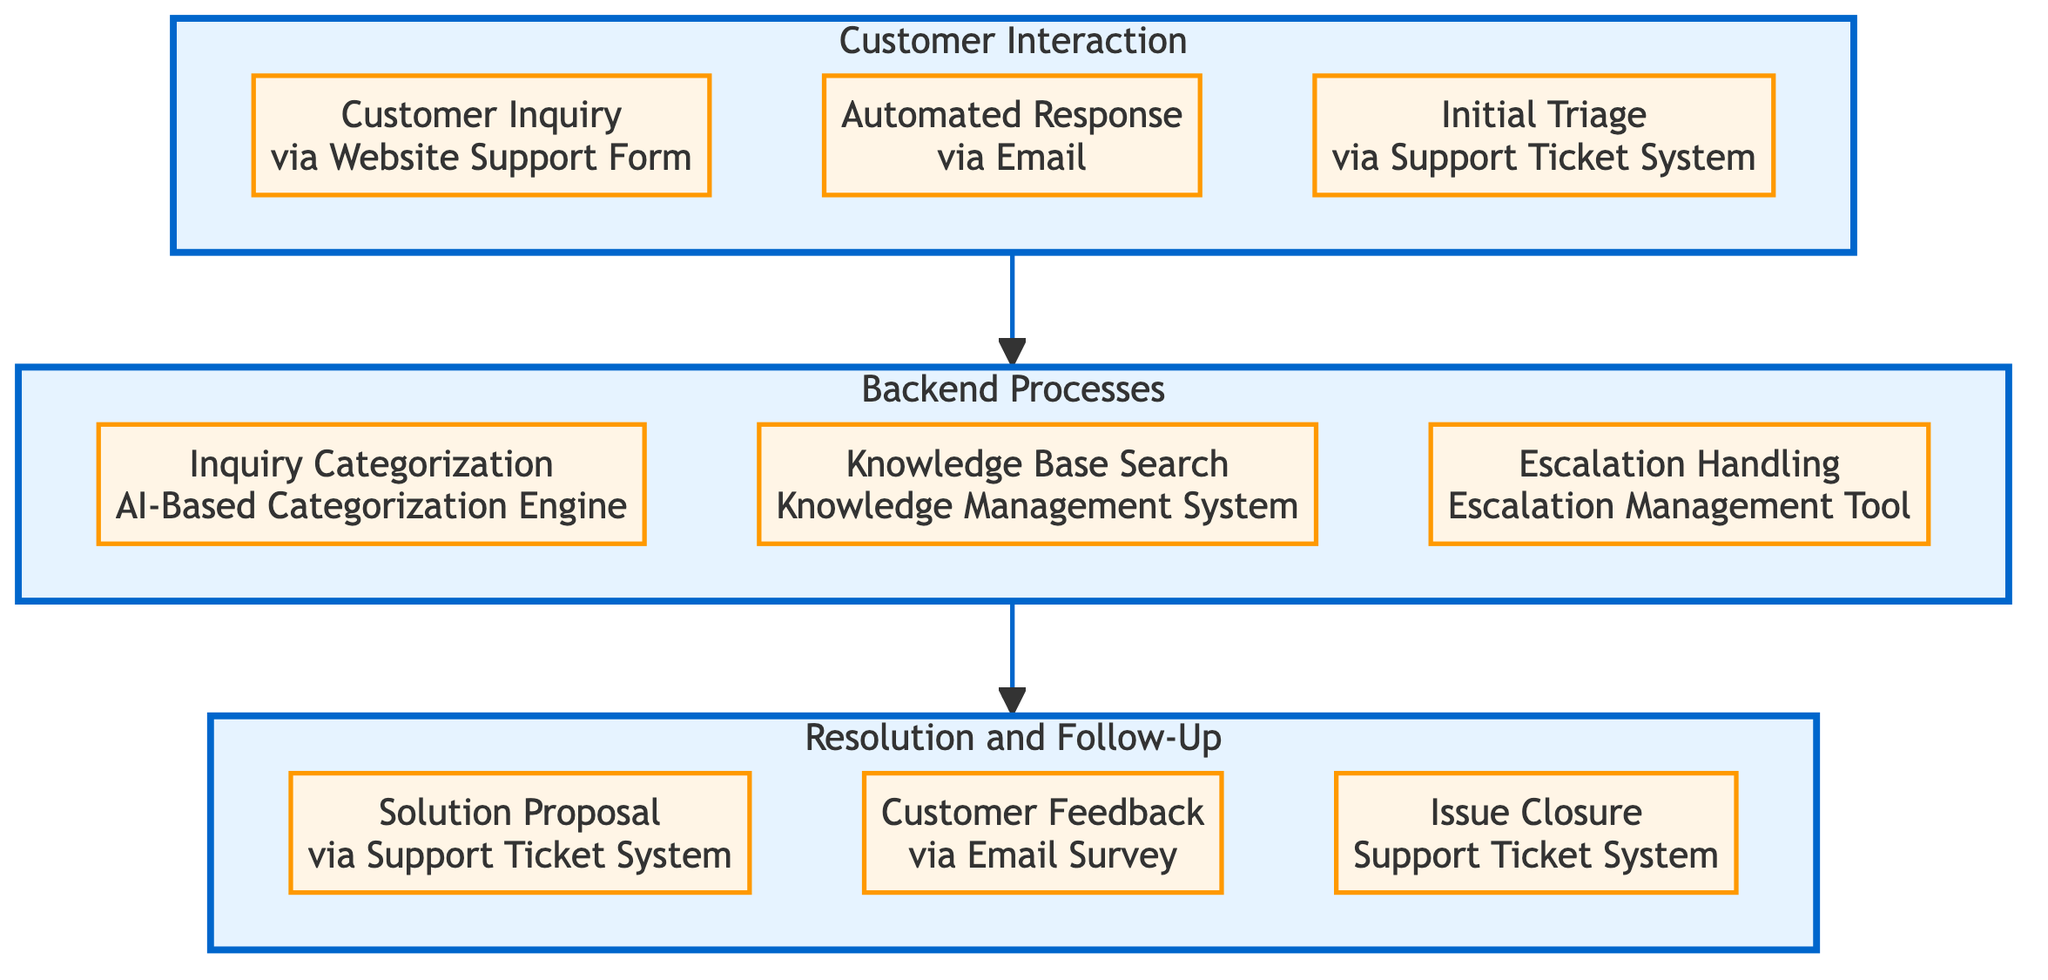What are the three main blocks in the diagram? The diagram contains three main blocks: Customer Interaction, Backend Processes, and Resolution and Follow-Up. Each block contains associated elements that represent different stages of the customer support function.
Answer: Customer Interaction, Backend Processes, Resolution and Follow-Up How many elements are in the "Backend Processes" block? The "Backend Processes" block contains three elements: Inquiry Categorization, Knowledge Base Search, and Escalation Handling. This can be counted visually from the block.
Answer: Three What channels are used for "Customer Inquiry"? The "Customer Inquiry" element specifies that the inquiry is submitted via the Website Support Form. The associated channel is explicitly stated in its description.
Answer: Website Support Form Which process handles complex inquiries? The "Escalation Handling" element is responsible for managing complex inquiries that need special attention by tier 2 support. This can be identified by referring to the description provided under that element.
Answer: Escalation Handling What is the technology associated with "Knowledge Base Search"? The "Knowledge Base Search" element mentions the Knowledge Management System as the technology utilized for searching relevant articles. This is specified in the element's description.
Answer: Knowledge Management System What happens after the "Solution Proposal" is provided? Once the "Solution Proposal" is made by the Customer Support Representative, the next step in the flow leads to obtaining "Customer Feedback." This extends from the Resolution and Follow-Up block's process.
Answer: Customer Feedback How many interactions occur before reaching resolution? There are three main interactions in the "Customer Interaction" block, which precede any backend processes leading to a resolution. This can be counted from the visual representation of the block.
Answer: Three Which channel is used to gather "Customer Feedback"? The "Customer Feedback" element states that an Email Survey is used as the channel to collect feedback from customers after they receive a solution proposal. This information is provided in the channel specification.
Answer: Email Survey What step follows "Inquiry Categorization" in the backend? Following "Inquiry Categorization," the next step in the backend processes is "Knowledge Base Search," as per the flow of the diagram from one block to the next.
Answer: Knowledge Base Search 